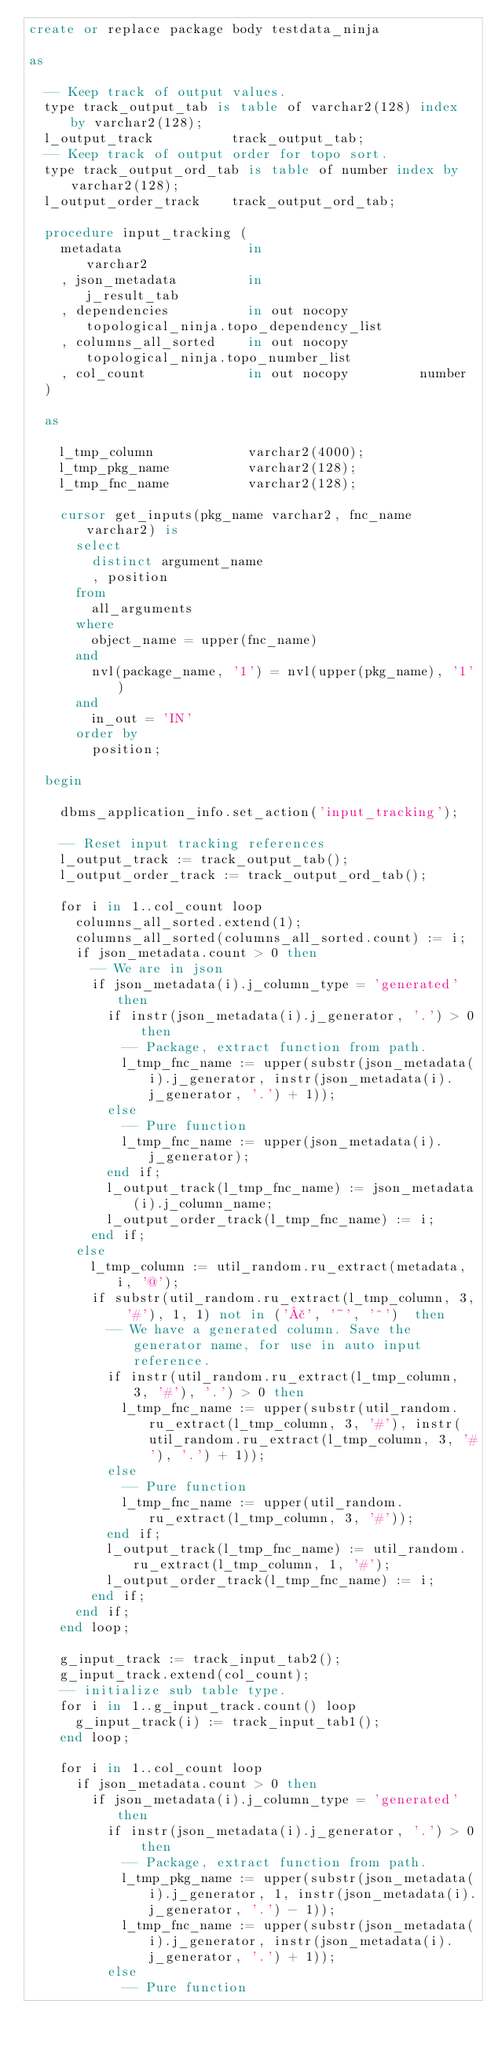Convert code to text. <code><loc_0><loc_0><loc_500><loc_500><_SQL_>create or replace package body testdata_ninja

as

  -- Keep track of output values.
  type track_output_tab is table of varchar2(128) index by varchar2(128);
  l_output_track          track_output_tab;
  -- Keep track of output order for topo sort.
  type track_output_ord_tab is table of number index by varchar2(128);
  l_output_order_track    track_output_ord_tab;

  procedure input_tracking (
    metadata                in                    varchar2
    , json_metadata         in                    j_result_tab
    , dependencies          in out nocopy         topological_ninja.topo_dependency_list
    , columns_all_sorted    in out nocopy         topological_ninja.topo_number_list
    , col_count             in out nocopy         number
  )

  as

    l_tmp_column            varchar2(4000);
    l_tmp_pkg_name          varchar2(128);
    l_tmp_fnc_name          varchar2(128);

    cursor get_inputs(pkg_name varchar2, fnc_name varchar2) is
      select
        distinct argument_name
        , position
      from
        all_arguments
      where
        object_name = upper(fnc_name)
      and
        nvl(package_name, '1') = nvl(upper(pkg_name), '1')
      and
        in_out = 'IN'
      order by
        position;

  begin

    dbms_application_info.set_action('input_tracking');

    -- Reset input tracking references
    l_output_track := track_output_tab();
    l_output_order_track := track_output_ord_tab();

    for i in 1..col_count loop
      columns_all_sorted.extend(1);
      columns_all_sorted(columns_all_sorted.count) := i;
      if json_metadata.count > 0 then
        -- We are in json
        if json_metadata(i).j_column_type = 'generated' then
          if instr(json_metadata(i).j_generator, '.') > 0 then
            -- Package, extract function from path.
            l_tmp_fnc_name := upper(substr(json_metadata(i).j_generator, instr(json_metadata(i).j_generator, '.') + 1));
          else
            -- Pure function
            l_tmp_fnc_name := upper(json_metadata(i).j_generator);
          end if;
          l_output_track(l_tmp_fnc_name) := json_metadata(i).j_column_name;
          l_output_order_track(l_tmp_fnc_name) := i;
        end if;
      else
        l_tmp_column := util_random.ru_extract(metadata, i, '@');
        if substr(util_random.ru_extract(l_tmp_column, 3, '#'), 1, 1) not in ('£', '~', '^')  then
          -- We have a generated column. Save the generator name, for use in auto input reference.
          if instr(util_random.ru_extract(l_tmp_column, 3, '#'), '.') > 0 then
            l_tmp_fnc_name := upper(substr(util_random.ru_extract(l_tmp_column, 3, '#'), instr(util_random.ru_extract(l_tmp_column, 3, '#'), '.') + 1));
          else
            -- Pure function
            l_tmp_fnc_name := upper(util_random.ru_extract(l_tmp_column, 3, '#'));
          end if;
          l_output_track(l_tmp_fnc_name) := util_random.ru_extract(l_tmp_column, 1, '#');
          l_output_order_track(l_tmp_fnc_name) := i;
        end if;
      end if;
    end loop;

    g_input_track := track_input_tab2();
    g_input_track.extend(col_count);
    -- initialize sub table type.
    for i in 1..g_input_track.count() loop
      g_input_track(i) := track_input_tab1();
    end loop;

    for i in 1..col_count loop
      if json_metadata.count > 0 then
        if json_metadata(i).j_column_type = 'generated' then
          if instr(json_metadata(i).j_generator, '.') > 0 then
            -- Package, extract function from path.
            l_tmp_pkg_name := upper(substr(json_metadata(i).j_generator, 1, instr(json_metadata(i).j_generator, '.') - 1));
            l_tmp_fnc_name := upper(substr(json_metadata(i).j_generator, instr(json_metadata(i).j_generator, '.') + 1));
          else
            -- Pure function</code> 